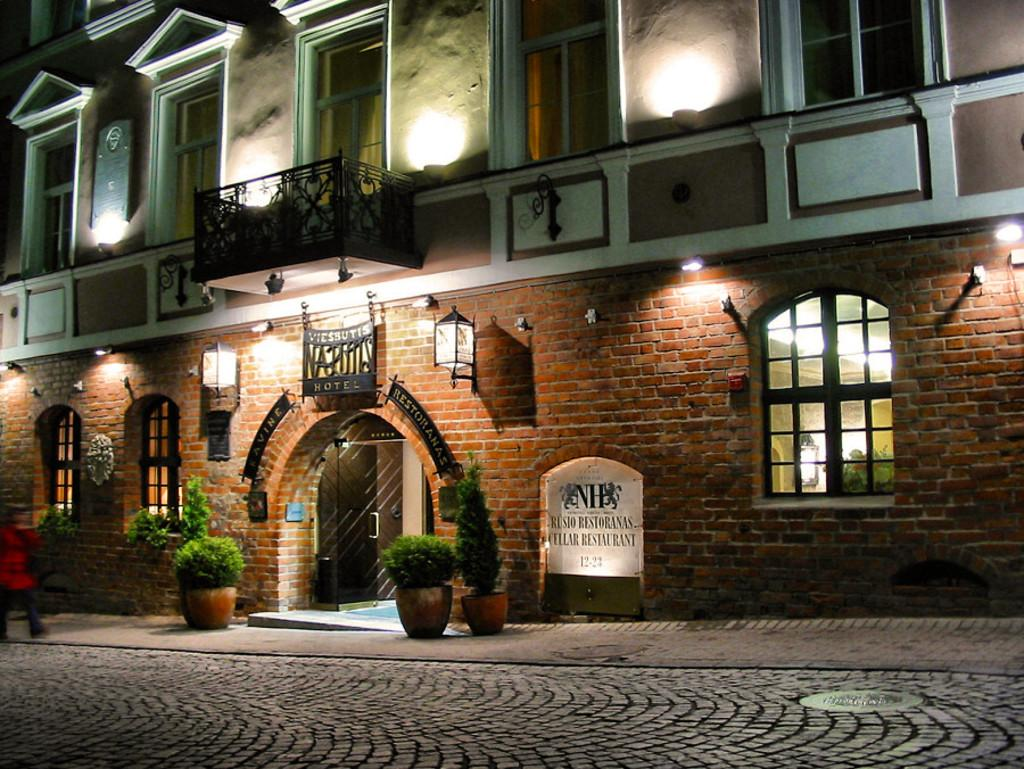Provide a one-sentence caption for the provided image. A brick motel several stories tall called Viessutis. 